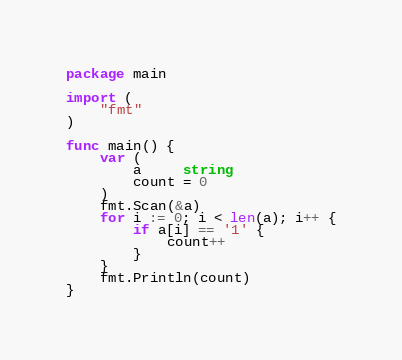Convert code to text. <code><loc_0><loc_0><loc_500><loc_500><_Go_>package main

import (
	"fmt"
)

func main() {
	var (
		a     string
		count = 0
	)
	fmt.Scan(&a)
	for i := 0; i < len(a); i++ {
		if a[i] == '1' {
			count++
		}
	}
	fmt.Println(count)
}
</code> 